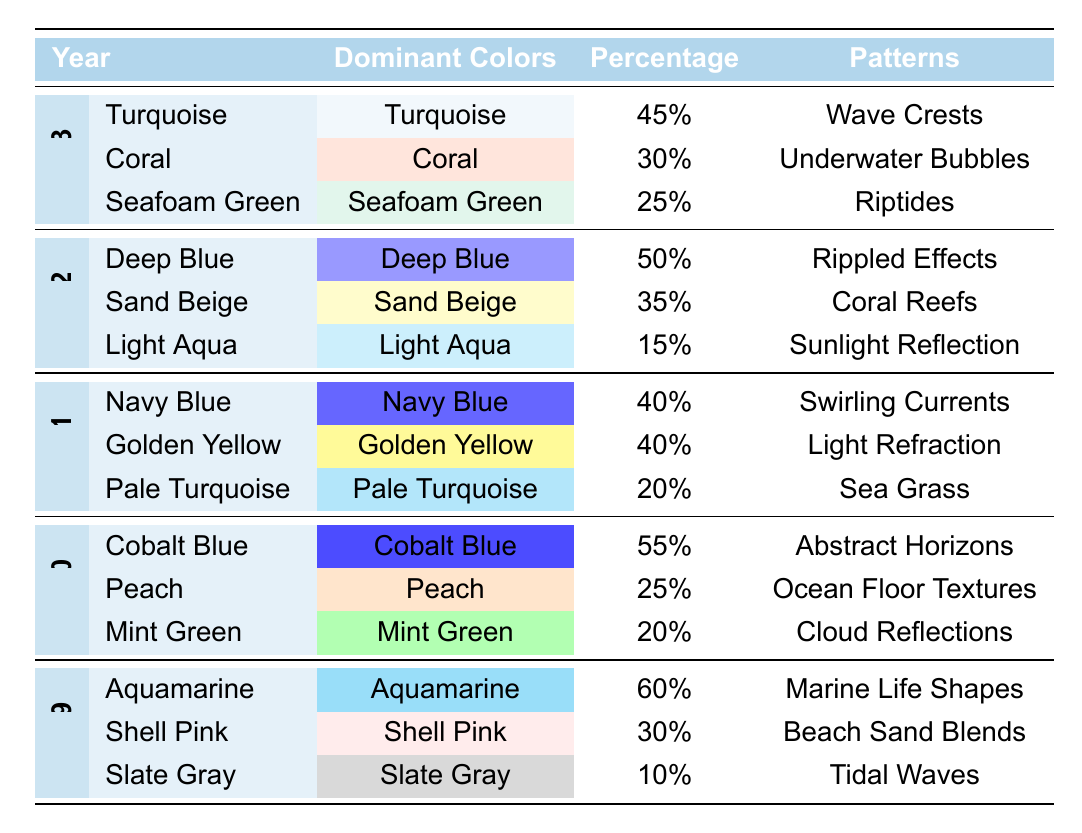What are the dominant colors in 2023? According to the table, the dominant colors for 2023 are Turquoise, Coral, and Seafoam Green.
Answer: Turquoise, Coral, Seafoam Green Which color had the highest percentage in 2022? The table shows that Deep Blue had the highest percentage in 2022, at 50%.
Answer: Deep Blue What is the total percentage of the dominant colors in 2021? To find the total percentage for 2021, we sum the individual percentages: 40% (Navy Blue) + 40% (Golden Yellow) + 20% (Pale Turquoise) = 100%.
Answer: 100% Is Mint Green more dominant than Peach in 2020? In the year 2020, Mint Green had a percentage of 20% and Peach had a percentage of 25%. Since 20% is less than 25%, Mint Green is not more dominant.
Answer: No What pattern was associated with the dominant color Coral in 2023? The table indicates that Coral was linked to the pattern "Underwater Bubbles" in 2023.
Answer: Underwater Bubbles What is the average percentage of the dominant colors for 2019 and 2020? For 2019, the percentages are 60% (Aquamarine), 30% (Shell Pink), 10% (Slate Gray), which total to 100%. For 2020, the percentages are 55% (Cobalt Blue), 25% (Peach), 20% (Mint Green), which also total to 100%. Totaling the averages: (100 + 100) / 2 = 100.
Answer: 100 How many patterns are listed for 2022? The table shows three patterns listed for 2022: Rippled Effects, Coral Reefs, and Sunlight Reflection. Therefore, there are three patterns.
Answer: 3 Which year had the most dominant color percentages that were above 40%? Looking at the years, 2020 has Cobalt Blue (55%), and both 2019 and 2021 have colors with percentages above 40%, but 2020 has a single color above 50%. 2022 has Deep Blue (50%). Since both 2020 and 2022 have dominant percentages above 40%, we note both years but more than one color applies to 2021 and 2023.
Answer: 2020 and 2022 Was Seafoam Green a dominant color in 2022? The table does not list Seafoam Green as a dominant color in 2022; it only appears in 2023.
Answer: No 